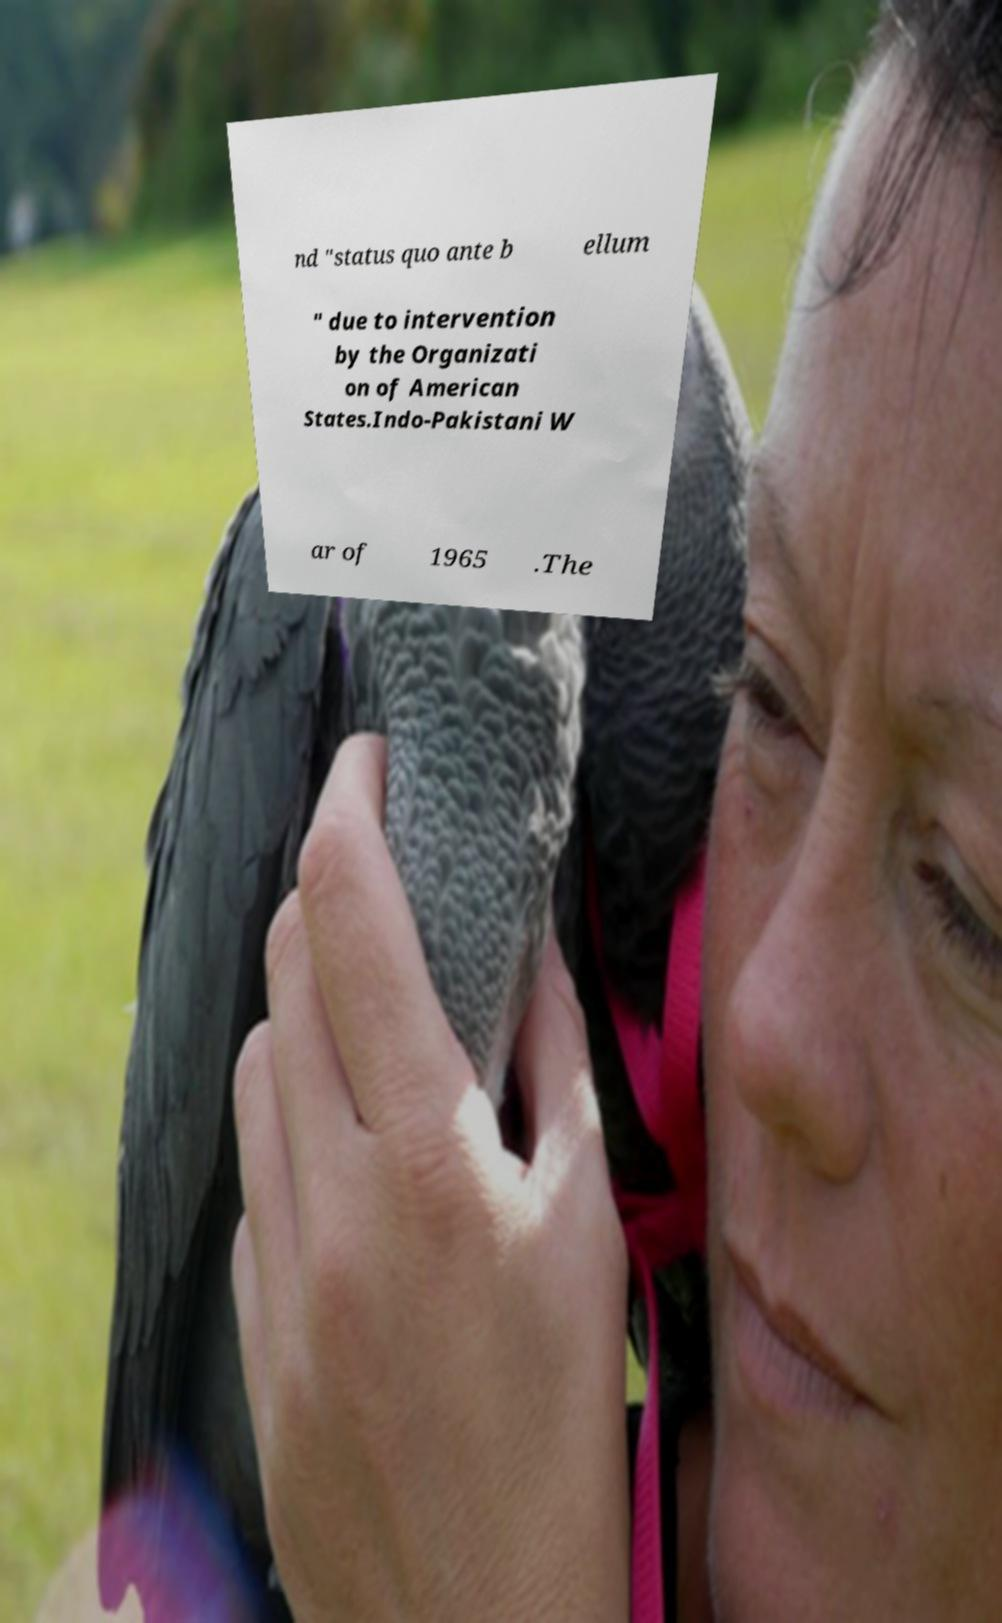Please read and relay the text visible in this image. What does it say? nd "status quo ante b ellum " due to intervention by the Organizati on of American States.Indo-Pakistani W ar of 1965 .The 